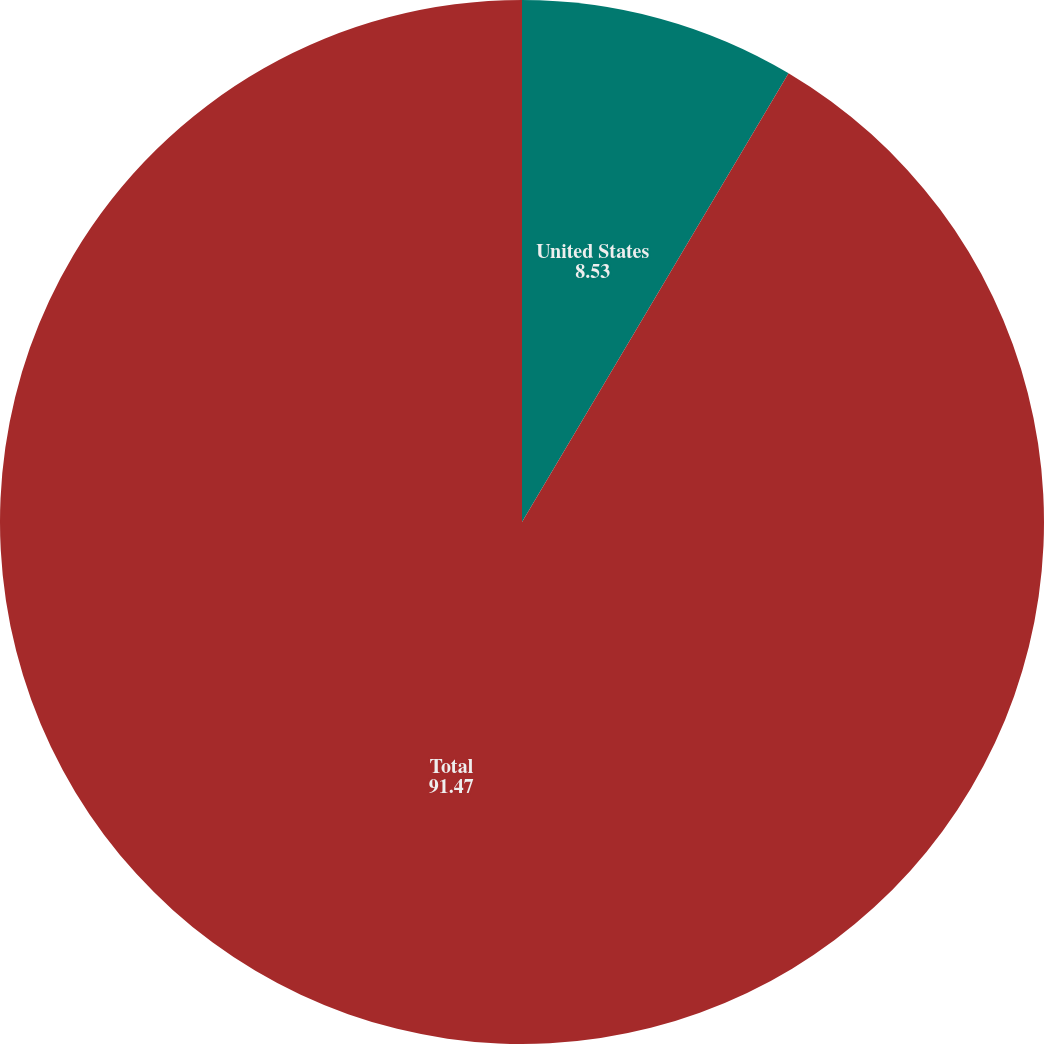Convert chart. <chart><loc_0><loc_0><loc_500><loc_500><pie_chart><fcel>United States<fcel>Total<nl><fcel>8.53%<fcel>91.47%<nl></chart> 